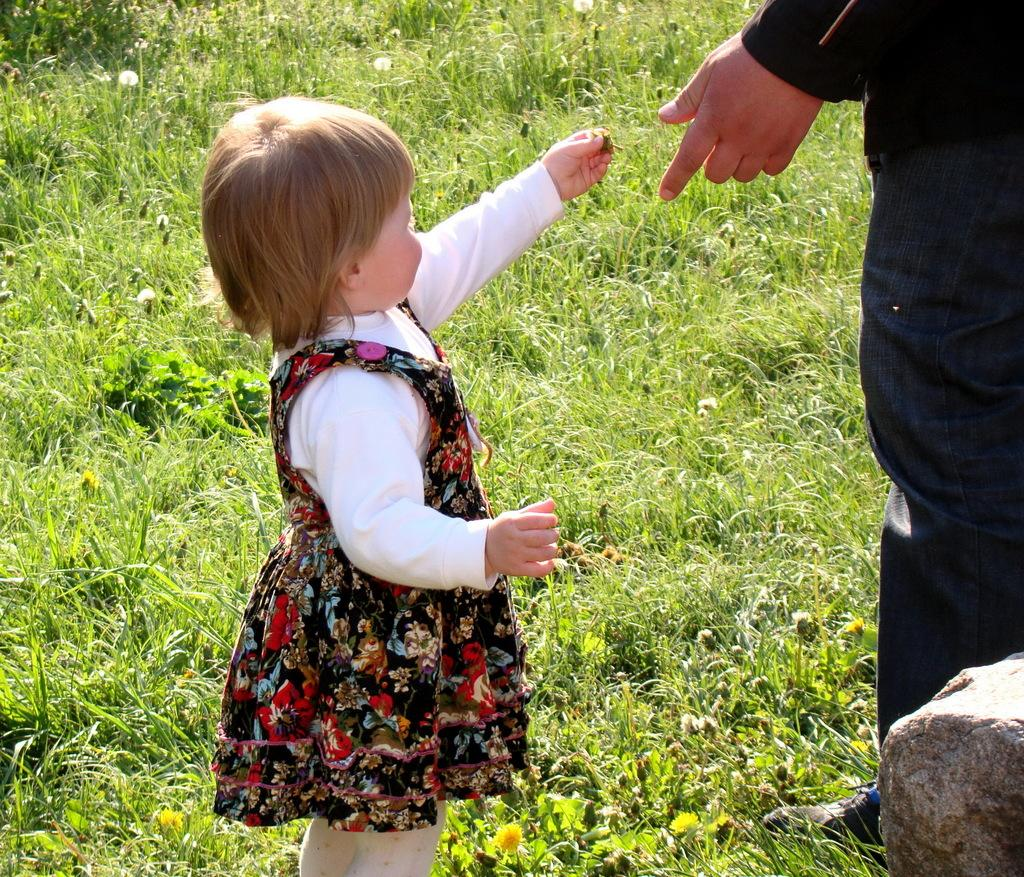Who is the main subject in the image? There is a small girl in the image. What is the girl holding in her hand? The girl is holding something in her hand, but we cannot determine what it is from the image. Can you describe the person standing on the right side of the image? There is a person standing on the right side of the image, but we cannot determine their age, gender, or any other details from the image. What type of natural elements can be seen in the image? There are plants on the ground in the image. What other object can be seen in the image? There is a stone in the image. What type of company is the girl representing in the image? There is no indication in the image that the girl is representing any company. 